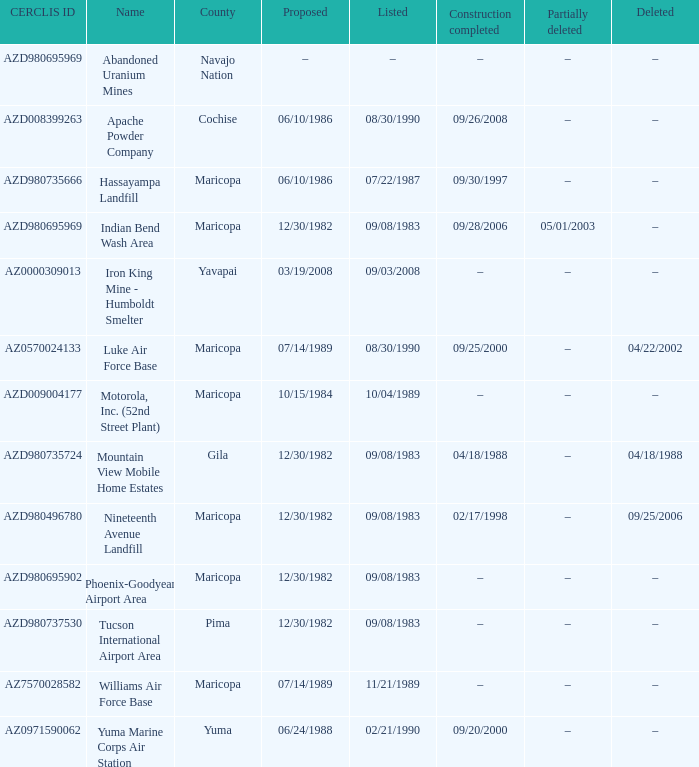What is the cerclis id when the site was proposed on 12/30/1982 and was partially deleted on 05/01/2003? AZD980695969. 